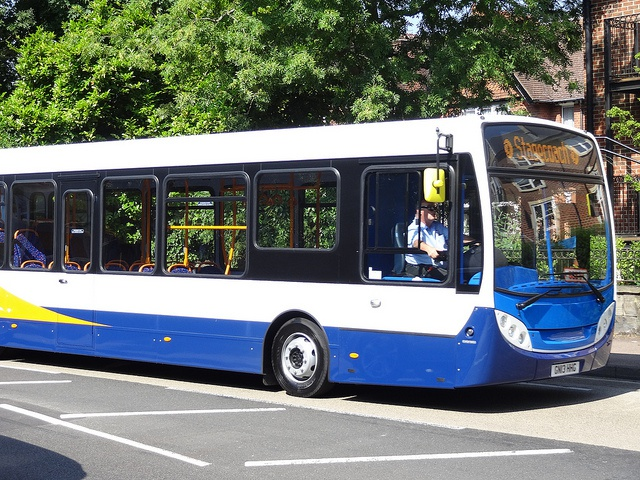Describe the objects in this image and their specific colors. I can see bus in black, white, blue, and gray tones and people in black, white, and gray tones in this image. 